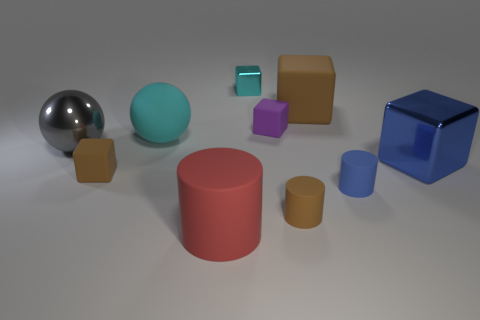Can you tell me about the different materials and shapes present in this image? Certainly! The image depicts a variety of objects with different materials and shapes. There's a shiny metal sphere, a teal matte ball, translucent cubes, and several matte objects including a red cylinder, brown cubes, and a purple cube. There's also a shiny blue cube, which stands out due to its reflective surface. 